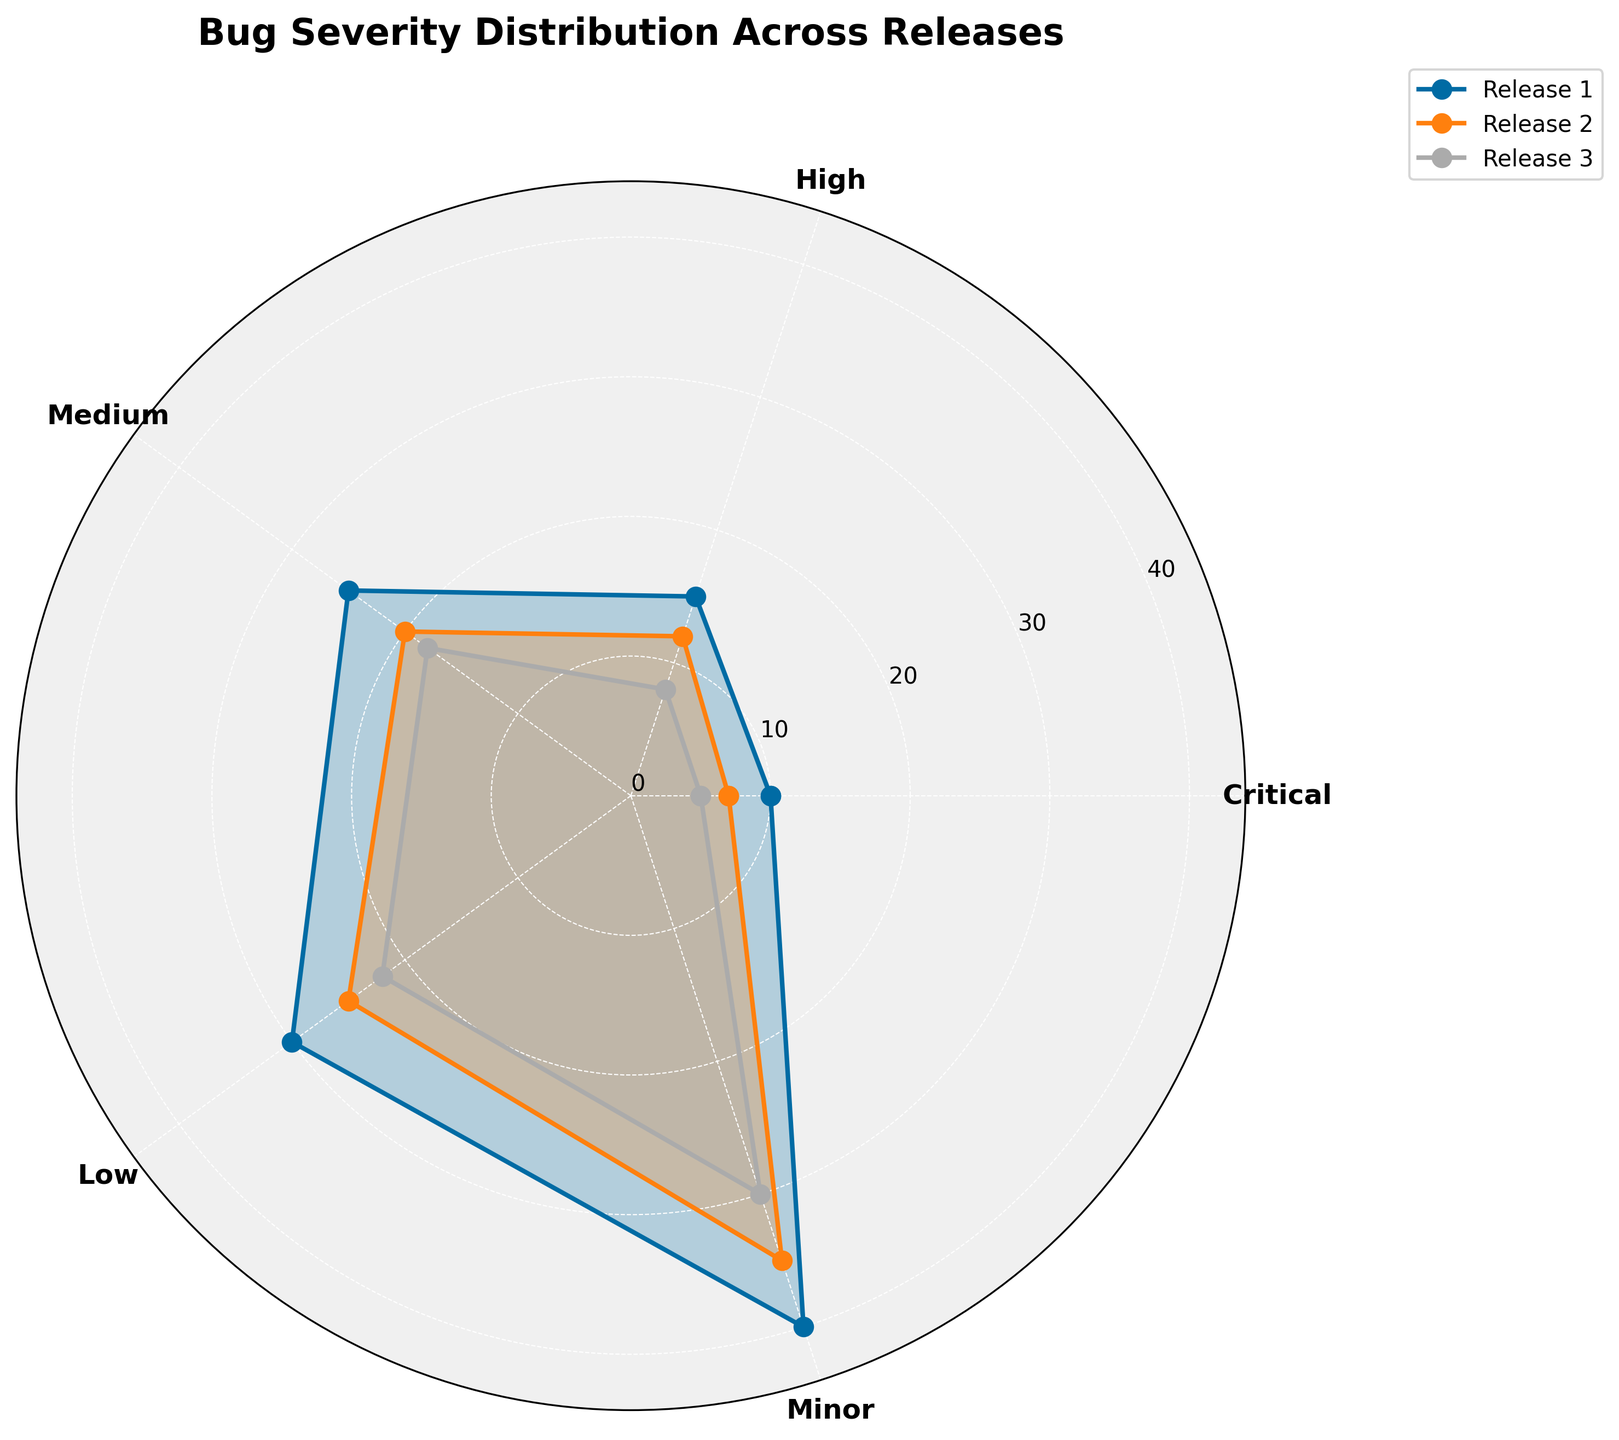How many categories of bug severity are there in the figure? The figure depicts a total of five categories of bug severity, each represented on the polar chart with its own label.
Answer: Five What is the title of the figure? The title of the figure is clearly stated at the top, which reads "Bug Severity Distribution Across Releases."
Answer: Bug Severity Distribution Across Releases Which release has the lowest count for Critical bugs? By examining the plotted lines on the polar chart, it is evident that Release 3 has the lowest count for Critical bugs, as its corresponding point is closest to the center.
Answer: Release 3 What is the total number of bugs in the Minor category across all releases? To find the total number of "Minor" bugs across all releases, you sum the counts from Release 1, Release 2, and Release 3: 40 + 35 + 30 = 105.
Answer: 105 Which release has the highest variability in bug severity counts? By visually comparing the angles and lengths of the plotted lines, Release 1 shows the highest variability as its values span the widest range from Critical (10) to Minor (40).
Answer: Release 1 How do the counts of Medium bugs compare between Release 1 and Release 2? The counts for Medium bugs in Release 1 and Release 2 are 25 and 20, respectively. Release 1 has more Medium bugs by a difference of 5.
Answer: Release 1 has 5 more Is there a consistent trend in the number of High severity bugs across the releases? Observing the plotted values for High severity bugs (15, 12, 8), there's a descending trend, with the count consistently decreasing from Release 1 to Release 3.
Answer: Yes, a decrease Which severity level has the most significant drop in bugs from Release 1 to Release 3? The counts for each severity from Release 1 to Release 3 are: Critical (10, 7, 5), High (15, 12, 8), Medium (25, 20, 18), Low (30, 25, 22), Minor (40, 35, 30). The significant drop is observed in the High severity level, which reduces by 7 bugs (15 to 8).
Answer: High What is the range of bug counts for the Low severity level? To find the range for Low severity: subtract the smallest count (Release 3: 22) from the largest count (Release 1: 30): 30 - 22 = 8.
Answer: 8 Overall, which severity level has the most consistent bug counts across all releases? Comparing the variations, the Medium severity level (25, 20, 18) has smaller deviations compared to others, indicating more consistency across the releases.
Answer: Medium 